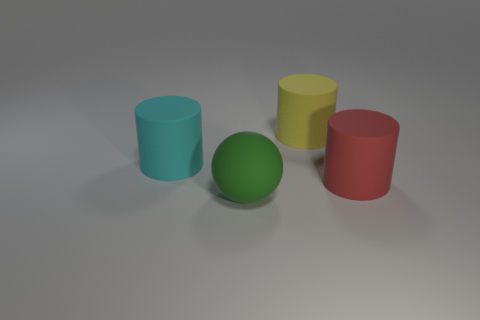Add 3 big green rubber balls. How many objects exist? 7 Subtract all balls. How many objects are left? 3 Subtract 0 brown cylinders. How many objects are left? 4 Subtract all green rubber things. Subtract all large gray matte balls. How many objects are left? 3 Add 1 large rubber balls. How many large rubber balls are left? 2 Add 2 small blue matte balls. How many small blue matte balls exist? 2 